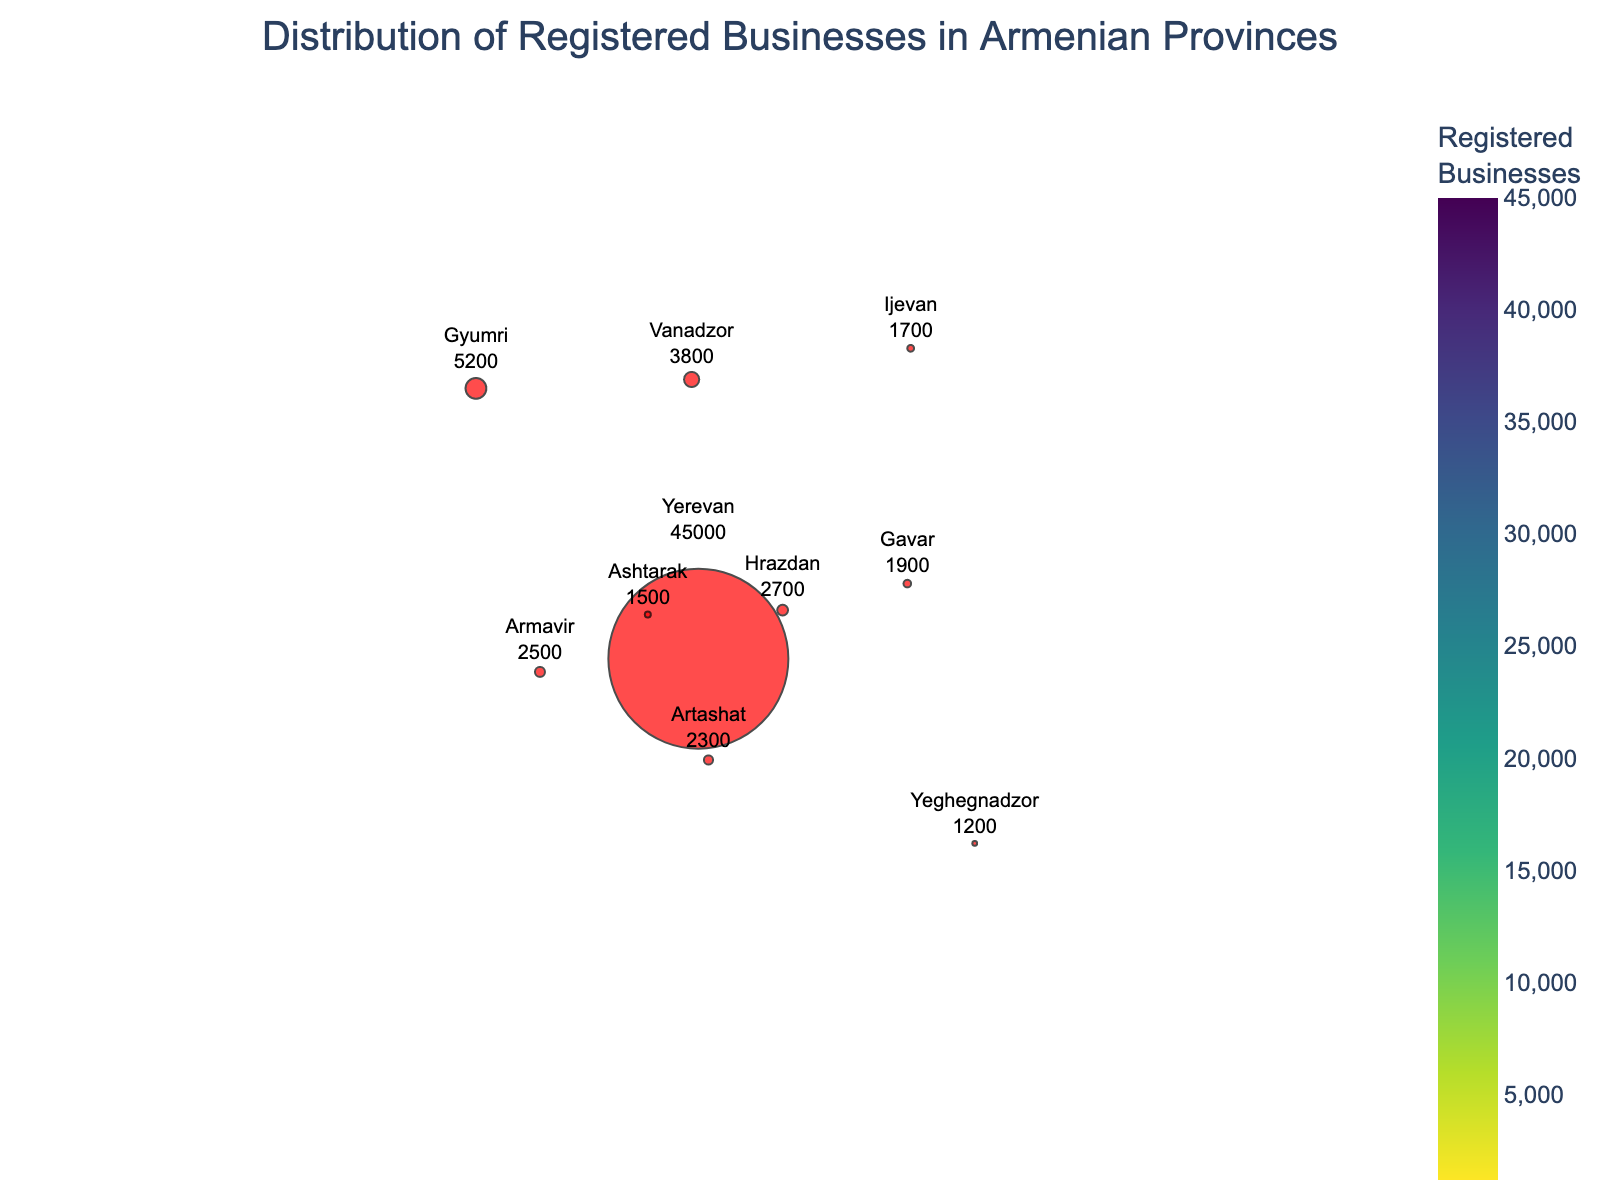What's the province with the highest number of registered businesses? Look at the color scales and hover information in the figure to identify the province with the darkest color, which typically indicates a higher number. From the data given, Yerevan has the highest number.
Answer: Yerevan How many registered businesses are there in Gyumri? Hover over the Gyumri city marker to see the number of registered businesses. According to the data, there are 5200 registered businesses.
Answer: 5200 Which city has a higher number of registered businesses, Artashat or Gavar? Compare the number of registered businesses indicated by hover information over the markers for Artashat and Gavar. Artashat has 2300, and Gavar has 1900.
Answer: Artashat What's the total number of registered businesses across all Armenian provinces? Add the numbers of registered businesses from each city: 45000+5200+3800+2700+2500+2300+2100+1900+1700+1500+1200.
Answer: 66800 What's the average number of registered businesses per province? Divide the total number of registered businesses by the number of provinces (11). 66800 / 11 gives an average.
Answer: 6072.73 Which province has the smallest number of registered businesses? Look for the province with the lightest color, indicating the lowest number. From the data, Vayots Dzor has 1200 registered businesses.
Answer: Vayots Dzor How does the number of registered businesses in Vanadzor compare to Yerevan? Compare the numbers directly. Vanadzor has 3800, while Yerevan has 45000.
Answer: Yerevan has more What's the difference in the number of registered businesses between Kapan and Armavir? Subtract the number of registered businesses in Kapan from Armavir: 2500 - 2100
Answer: 400 Which city represents the major business hub based on the figure? Identify the city marker with the largest size and the darkest color, indicating the highest density of registered businesses. Yerevan stands out as the major hub.
Answer: Yerevan What is the combined number of registered businesses for the provinces of Tavush and Aragatsotn? Add the number of registered businesses in Tavush and Aragatsotn: 1700 + 1500
Answer: 3200 